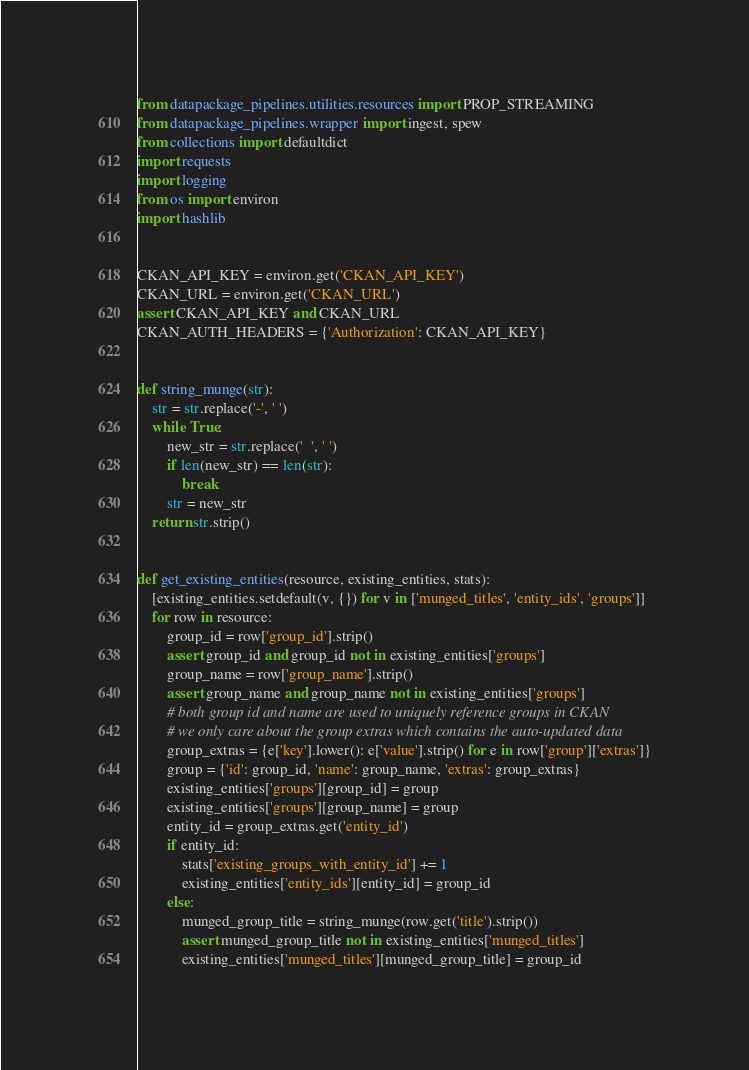<code> <loc_0><loc_0><loc_500><loc_500><_Python_>from datapackage_pipelines.utilities.resources import PROP_STREAMING
from datapackage_pipelines.wrapper import ingest, spew
from collections import defaultdict
import requests
import logging
from os import environ
import hashlib


CKAN_API_KEY = environ.get('CKAN_API_KEY')
CKAN_URL = environ.get('CKAN_URL')
assert CKAN_API_KEY and CKAN_URL
CKAN_AUTH_HEADERS = {'Authorization': CKAN_API_KEY}


def string_munge(str):
    str = str.replace('-', ' ')
    while True:
        new_str = str.replace('  ', ' ')
        if len(new_str) == len(str):
            break
        str = new_str
    return str.strip()


def get_existing_entities(resource, existing_entities, stats):
    [existing_entities.setdefault(v, {}) for v in ['munged_titles', 'entity_ids', 'groups']]
    for row in resource:
        group_id = row['group_id'].strip()
        assert group_id and group_id not in existing_entities['groups']
        group_name = row['group_name'].strip()
        assert group_name and group_name not in existing_entities['groups']
        # both group id and name are used to uniquely reference groups in CKAN
        # we only care about the group extras which contains the auto-updated data
        group_extras = {e['key'].lower(): e['value'].strip() for e in row['group']['extras']}
        group = {'id': group_id, 'name': group_name, 'extras': group_extras}
        existing_entities['groups'][group_id] = group
        existing_entities['groups'][group_name] = group
        entity_id = group_extras.get('entity_id')
        if entity_id:
            stats['existing_groups_with_entity_id'] += 1
            existing_entities['entity_ids'][entity_id] = group_id
        else:
            munged_group_title = string_munge(row.get('title').strip())
            assert munged_group_title not in existing_entities['munged_titles']
            existing_entities['munged_titles'][munged_group_title] = group_id</code> 